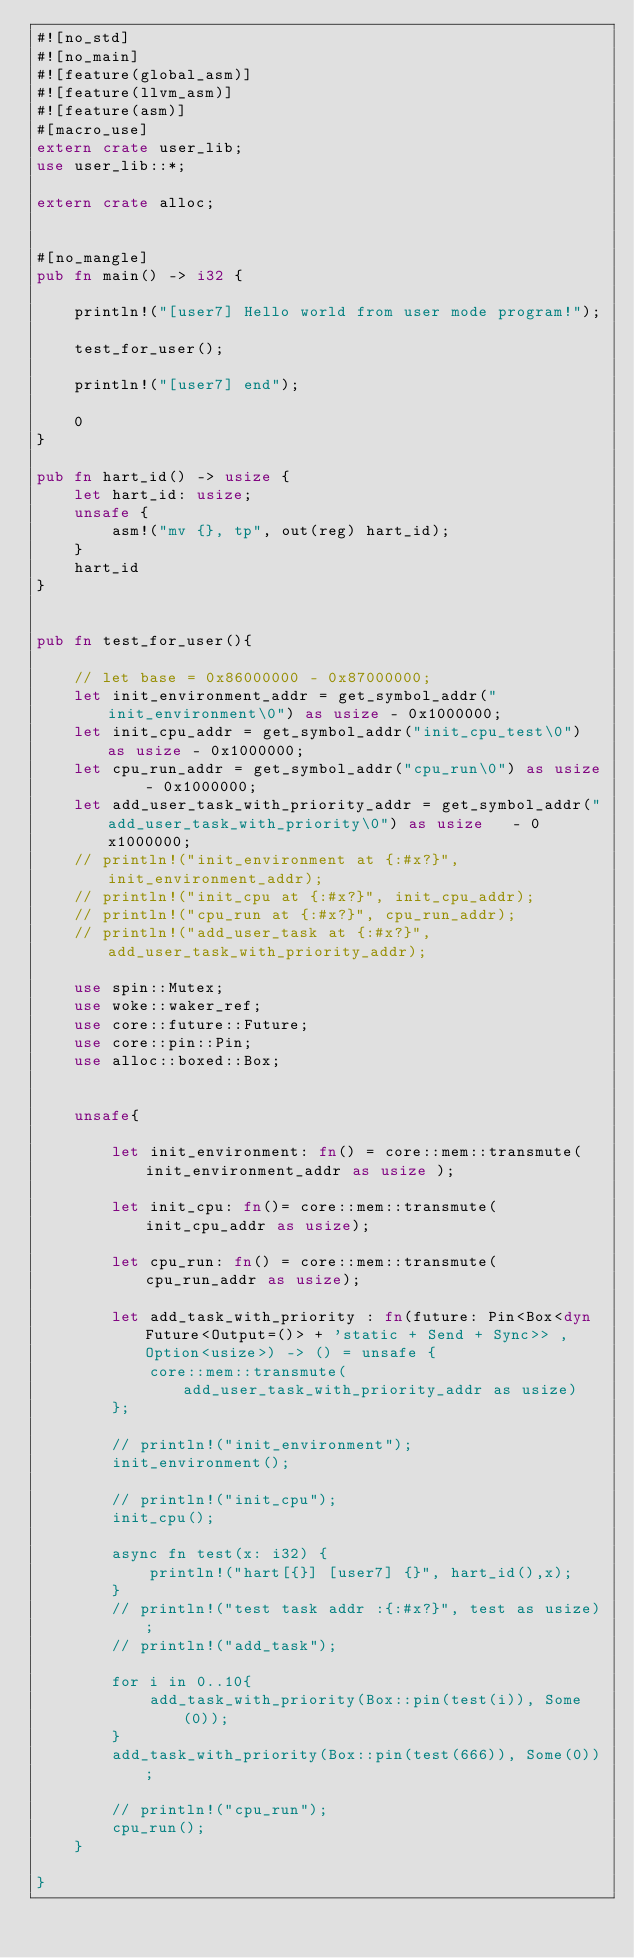Convert code to text. <code><loc_0><loc_0><loc_500><loc_500><_Rust_>#![no_std]
#![no_main]
#![feature(global_asm)]
#![feature(llvm_asm)]
#![feature(asm)]
#[macro_use]
extern crate user_lib;
use user_lib::*;

extern crate alloc;


#[no_mangle]
pub fn main() -> i32 {

    println!("[user7] Hello world from user mode program!");

    test_for_user();

    println!("[user7] end");

    0
}

pub fn hart_id() -> usize {
    let hart_id: usize;
    unsafe {
        asm!("mv {}, tp", out(reg) hart_id);
    }
    hart_id
}


pub fn test_for_user(){

    // let base = 0x86000000 - 0x87000000;
    let init_environment_addr = get_symbol_addr("init_environment\0") as usize - 0x1000000;
    let init_cpu_addr = get_symbol_addr("init_cpu_test\0") as usize - 0x1000000;
    let cpu_run_addr = get_symbol_addr("cpu_run\0") as usize    - 0x1000000;
    let add_user_task_with_priority_addr = get_symbol_addr("add_user_task_with_priority\0") as usize   - 0x1000000;
    // println!("init_environment at {:#x?}", init_environment_addr);
    // println!("init_cpu at {:#x?}", init_cpu_addr);
    // println!("cpu_run at {:#x?}", cpu_run_addr);
    // println!("add_user_task at {:#x?}", add_user_task_with_priority_addr);

    use spin::Mutex;
    use woke::waker_ref;
    use core::future::Future;
    use core::pin::Pin;
    use alloc::boxed::Box;


    unsafe{
        
        let init_environment: fn() = core::mem::transmute(init_environment_addr as usize );
        
        let init_cpu: fn()= core::mem::transmute(init_cpu_addr as usize);
        
        let cpu_run: fn() = core::mem::transmute(cpu_run_addr as usize);

        let add_task_with_priority : fn(future: Pin<Box<dyn Future<Output=()> + 'static + Send + Sync>> , Option<usize>) -> () = unsafe {
            core::mem::transmute(add_user_task_with_priority_addr as usize)
        };

        // println!("init_environment");
        init_environment();
        
        // println!("init_cpu");
        init_cpu();

        async fn test(x: i32) {
            println!("hart[{}] [user7] {}", hart_id(),x);
        }
        // println!("test task addr :{:#x?}", test as usize);
        // println!("add_task");

        for i in 0..10{
            add_task_with_priority(Box::pin(test(i)), Some(0));
        }
        add_task_with_priority(Box::pin(test(666)), Some(0));

        // println!("cpu_run");
        cpu_run();
    }

}</code> 